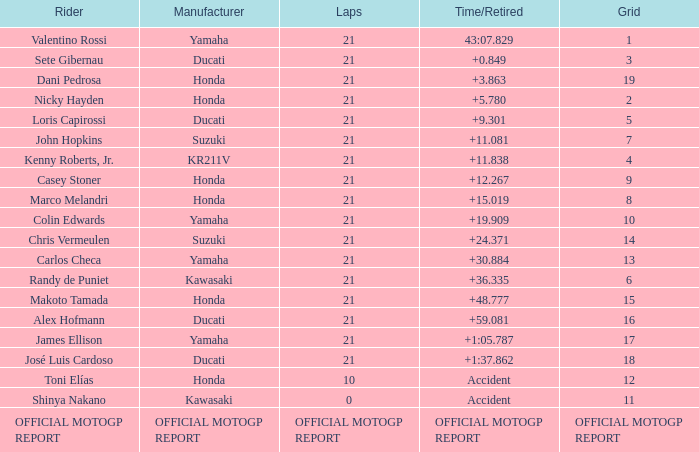What is the period/retired for the cyclist with the producer yamaha, grod of 1 and 21 complete laps? 43:07.829. 